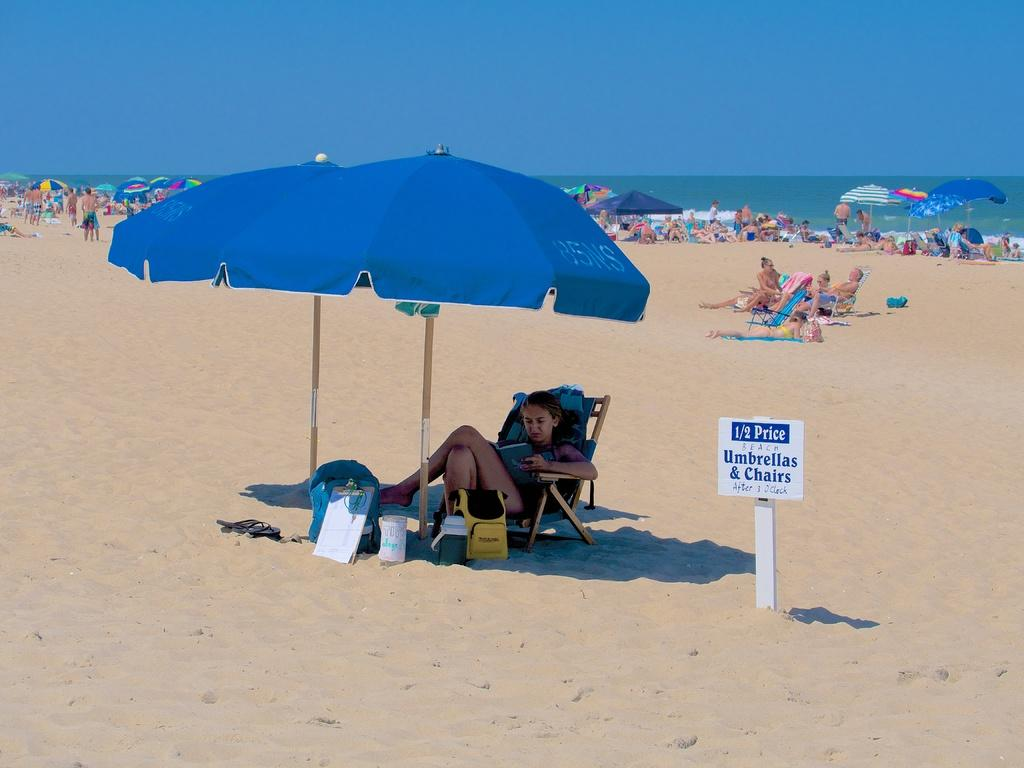What type of surface is visible in the image? There is sand in the image. What is the woman in the image doing? The woman is sitting on a chair and reading a book. What is providing shade in the image? There is an umbrella in the image. What is the condition of the sky in the image? The sky is clear in the image. How many balls are being juggled by the woman in the image? There are no balls present in the image; the woman is reading a book. What type of neck accessory is the woman wearing in the image? There is no neck accessory mentioned or visible in the image. 